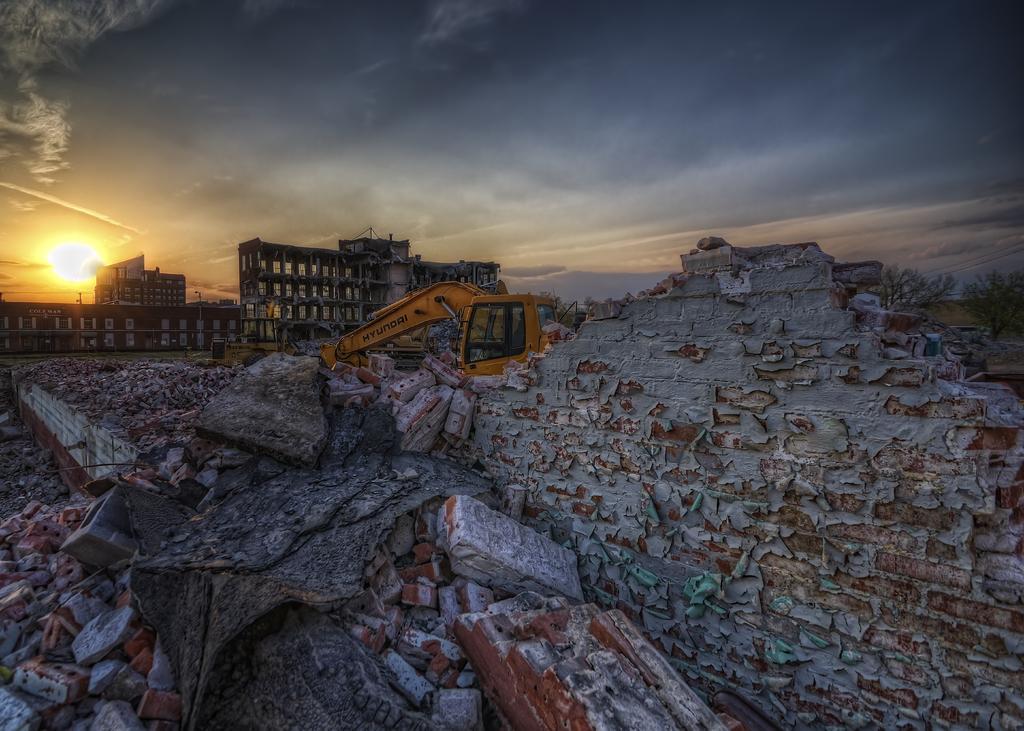Describe this image in one or two sentences. In this image we can see some bricks, buildings, trees and a crane, also we can see the destructed wall, in the background we can see the sun and the sky with clouds. 